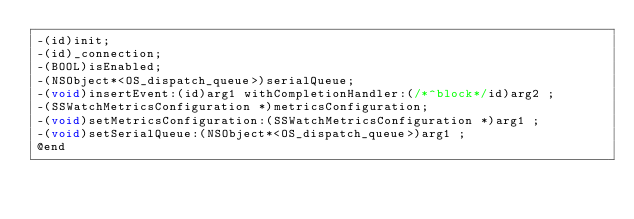Convert code to text. <code><loc_0><loc_0><loc_500><loc_500><_C_>-(id)init;
-(id)_connection;
-(BOOL)isEnabled;
-(NSObject*<OS_dispatch_queue>)serialQueue;
-(void)insertEvent:(id)arg1 withCompletionHandler:(/*^block*/id)arg2 ;
-(SSWatchMetricsConfiguration *)metricsConfiguration;
-(void)setMetricsConfiguration:(SSWatchMetricsConfiguration *)arg1 ;
-(void)setSerialQueue:(NSObject*<OS_dispatch_queue>)arg1 ;
@end

</code> 